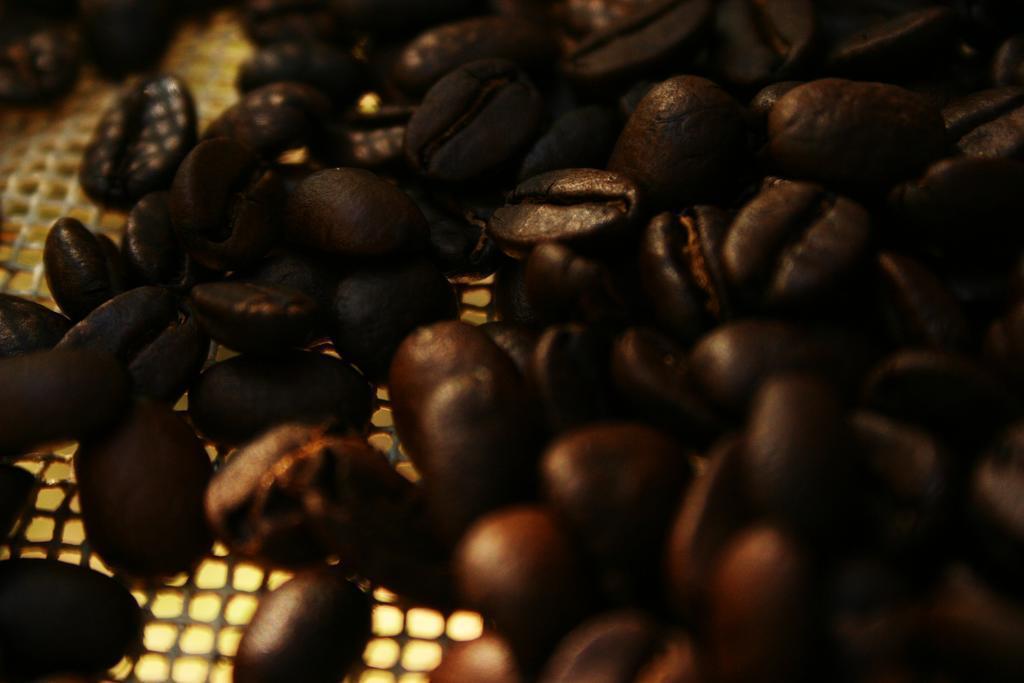Describe this image in one or two sentences. In this picture we can see coffee beans on a platform. 